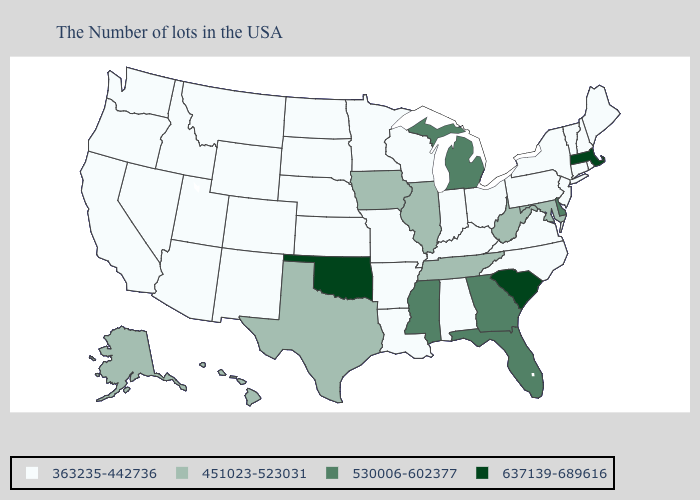Does the map have missing data?
Be succinct. No. Does Georgia have the lowest value in the USA?
Give a very brief answer. No. Name the states that have a value in the range 363235-442736?
Write a very short answer. Maine, Rhode Island, New Hampshire, Vermont, Connecticut, New York, New Jersey, Pennsylvania, Virginia, North Carolina, Ohio, Kentucky, Indiana, Alabama, Wisconsin, Louisiana, Missouri, Arkansas, Minnesota, Kansas, Nebraska, South Dakota, North Dakota, Wyoming, Colorado, New Mexico, Utah, Montana, Arizona, Idaho, Nevada, California, Washington, Oregon. Does the map have missing data?
Write a very short answer. No. What is the highest value in the USA?
Short answer required. 637139-689616. What is the value of South Dakota?
Write a very short answer. 363235-442736. Does the map have missing data?
Short answer required. No. What is the lowest value in the South?
Concise answer only. 363235-442736. Name the states that have a value in the range 637139-689616?
Be succinct. Massachusetts, South Carolina, Oklahoma. Does South Carolina have the highest value in the USA?
Answer briefly. Yes. Name the states that have a value in the range 363235-442736?
Quick response, please. Maine, Rhode Island, New Hampshire, Vermont, Connecticut, New York, New Jersey, Pennsylvania, Virginia, North Carolina, Ohio, Kentucky, Indiana, Alabama, Wisconsin, Louisiana, Missouri, Arkansas, Minnesota, Kansas, Nebraska, South Dakota, North Dakota, Wyoming, Colorado, New Mexico, Utah, Montana, Arizona, Idaho, Nevada, California, Washington, Oregon. Does the map have missing data?
Quick response, please. No. Name the states that have a value in the range 363235-442736?
Quick response, please. Maine, Rhode Island, New Hampshire, Vermont, Connecticut, New York, New Jersey, Pennsylvania, Virginia, North Carolina, Ohio, Kentucky, Indiana, Alabama, Wisconsin, Louisiana, Missouri, Arkansas, Minnesota, Kansas, Nebraska, South Dakota, North Dakota, Wyoming, Colorado, New Mexico, Utah, Montana, Arizona, Idaho, Nevada, California, Washington, Oregon. Name the states that have a value in the range 530006-602377?
Answer briefly. Delaware, Florida, Georgia, Michigan, Mississippi. Name the states that have a value in the range 451023-523031?
Answer briefly. Maryland, West Virginia, Tennessee, Illinois, Iowa, Texas, Alaska, Hawaii. 